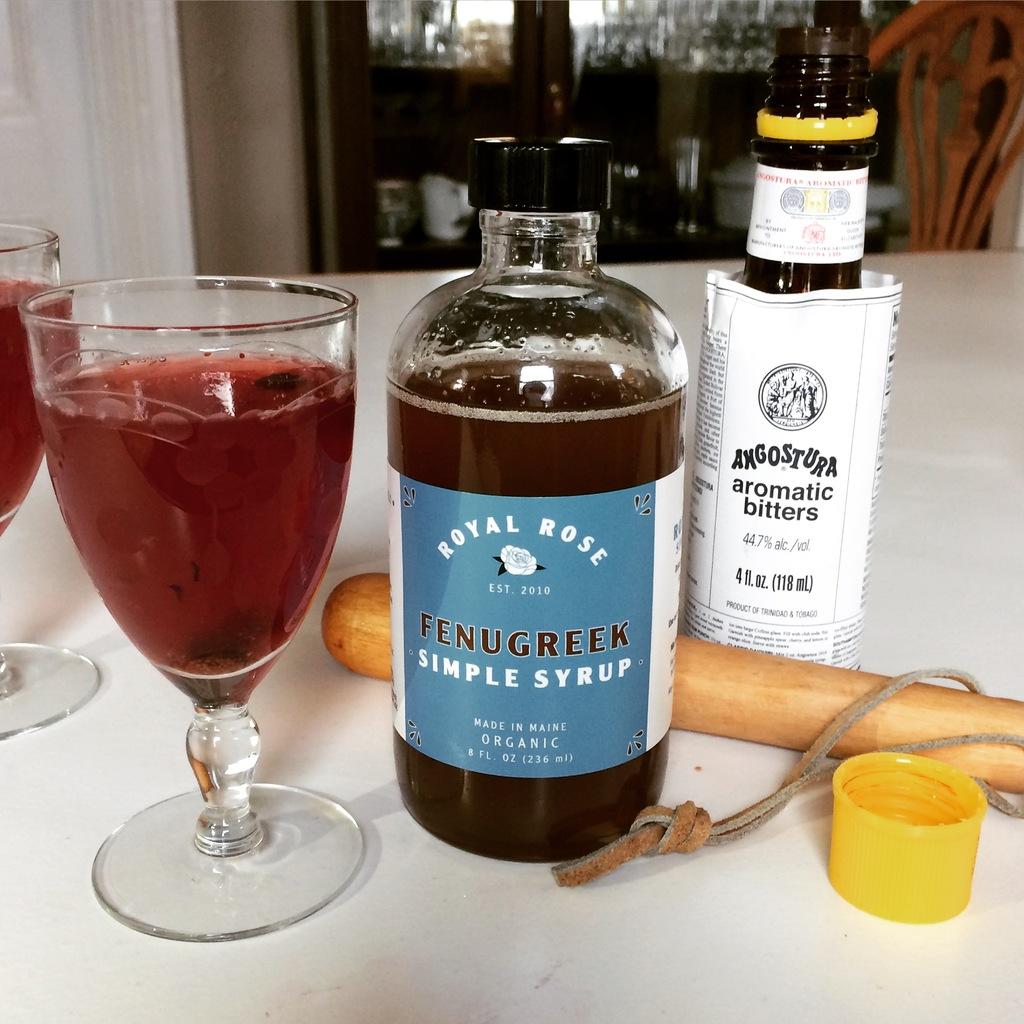When was royal rose established?
Your answer should be very brief. 2010. 